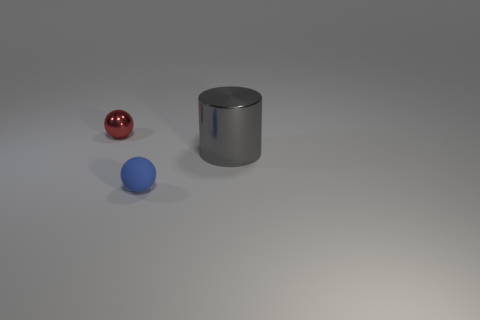What material is the other tiny object that is the same shape as the matte object?
Your answer should be compact. Metal. Is there any other thing that is made of the same material as the blue ball?
Your answer should be very brief. No. There is a thing that is both behind the matte sphere and on the left side of the gray object; what material is it?
Your answer should be compact. Metal. What number of other things have the same shape as the tiny metallic thing?
Make the answer very short. 1. What is the color of the sphere that is in front of the metal thing that is left of the large metal thing?
Provide a succinct answer. Blue. Is the number of red shiny spheres behind the large gray shiny cylinder the same as the number of shiny cylinders?
Offer a very short reply. Yes. Are there any other balls that have the same size as the red sphere?
Keep it short and to the point. Yes. Is the size of the gray metal thing the same as the ball that is in front of the red object?
Keep it short and to the point. No. Are there the same number of red balls in front of the tiny red sphere and big cylinders in front of the big gray metal cylinder?
Provide a short and direct response. Yes. What material is the ball in front of the cylinder?
Your answer should be compact. Rubber. 